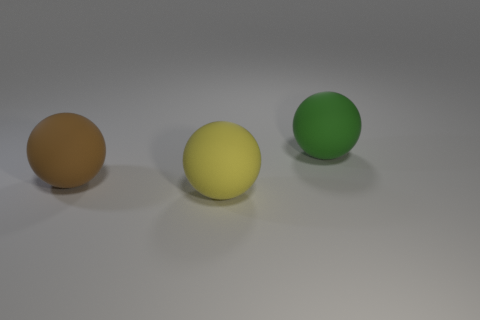How many big things are either yellow rubber things or green matte things?
Your answer should be compact. 2. What number of small cyan things have the same shape as the big green object?
Make the answer very short. 0. What number of big objects are in front of the green rubber ball?
Provide a short and direct response. 2. Are there any brown balls of the same size as the green matte sphere?
Your answer should be compact. Yes. Are any big brown matte things visible?
Your answer should be very brief. Yes. Are there an equal number of brown objects that are in front of the large yellow thing and balls?
Offer a terse response. No. Is the yellow rubber object the same shape as the large brown object?
Provide a succinct answer. Yes. What number of things are either large matte things that are on the left side of the yellow sphere or small purple rubber blocks?
Your answer should be very brief. 1. Is the number of green balls right of the large green object the same as the number of matte balls to the right of the brown matte sphere?
Keep it short and to the point. No. How many other things are the same shape as the big yellow rubber object?
Provide a short and direct response. 2. 